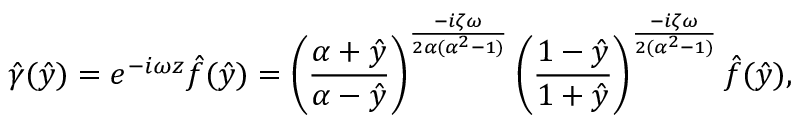<formula> <loc_0><loc_0><loc_500><loc_500>\hat { \gamma } ( \hat { y } ) = e ^ { - i \omega z } \hat { f } ( \hat { y } ) = \left ( \frac { \alpha + \hat { y } } { \alpha - \hat { y } } \right ) ^ { \frac { - i \zeta \omega } { 2 \alpha ( \alpha ^ { 2 } - 1 ) } } \left ( \frac { 1 - \hat { y } } { 1 + \hat { y } } \right ) ^ { \frac { - i \zeta \omega } { 2 ( \alpha ^ { 2 } - 1 ) } } \hat { f } ( \hat { y } ) ,</formula> 